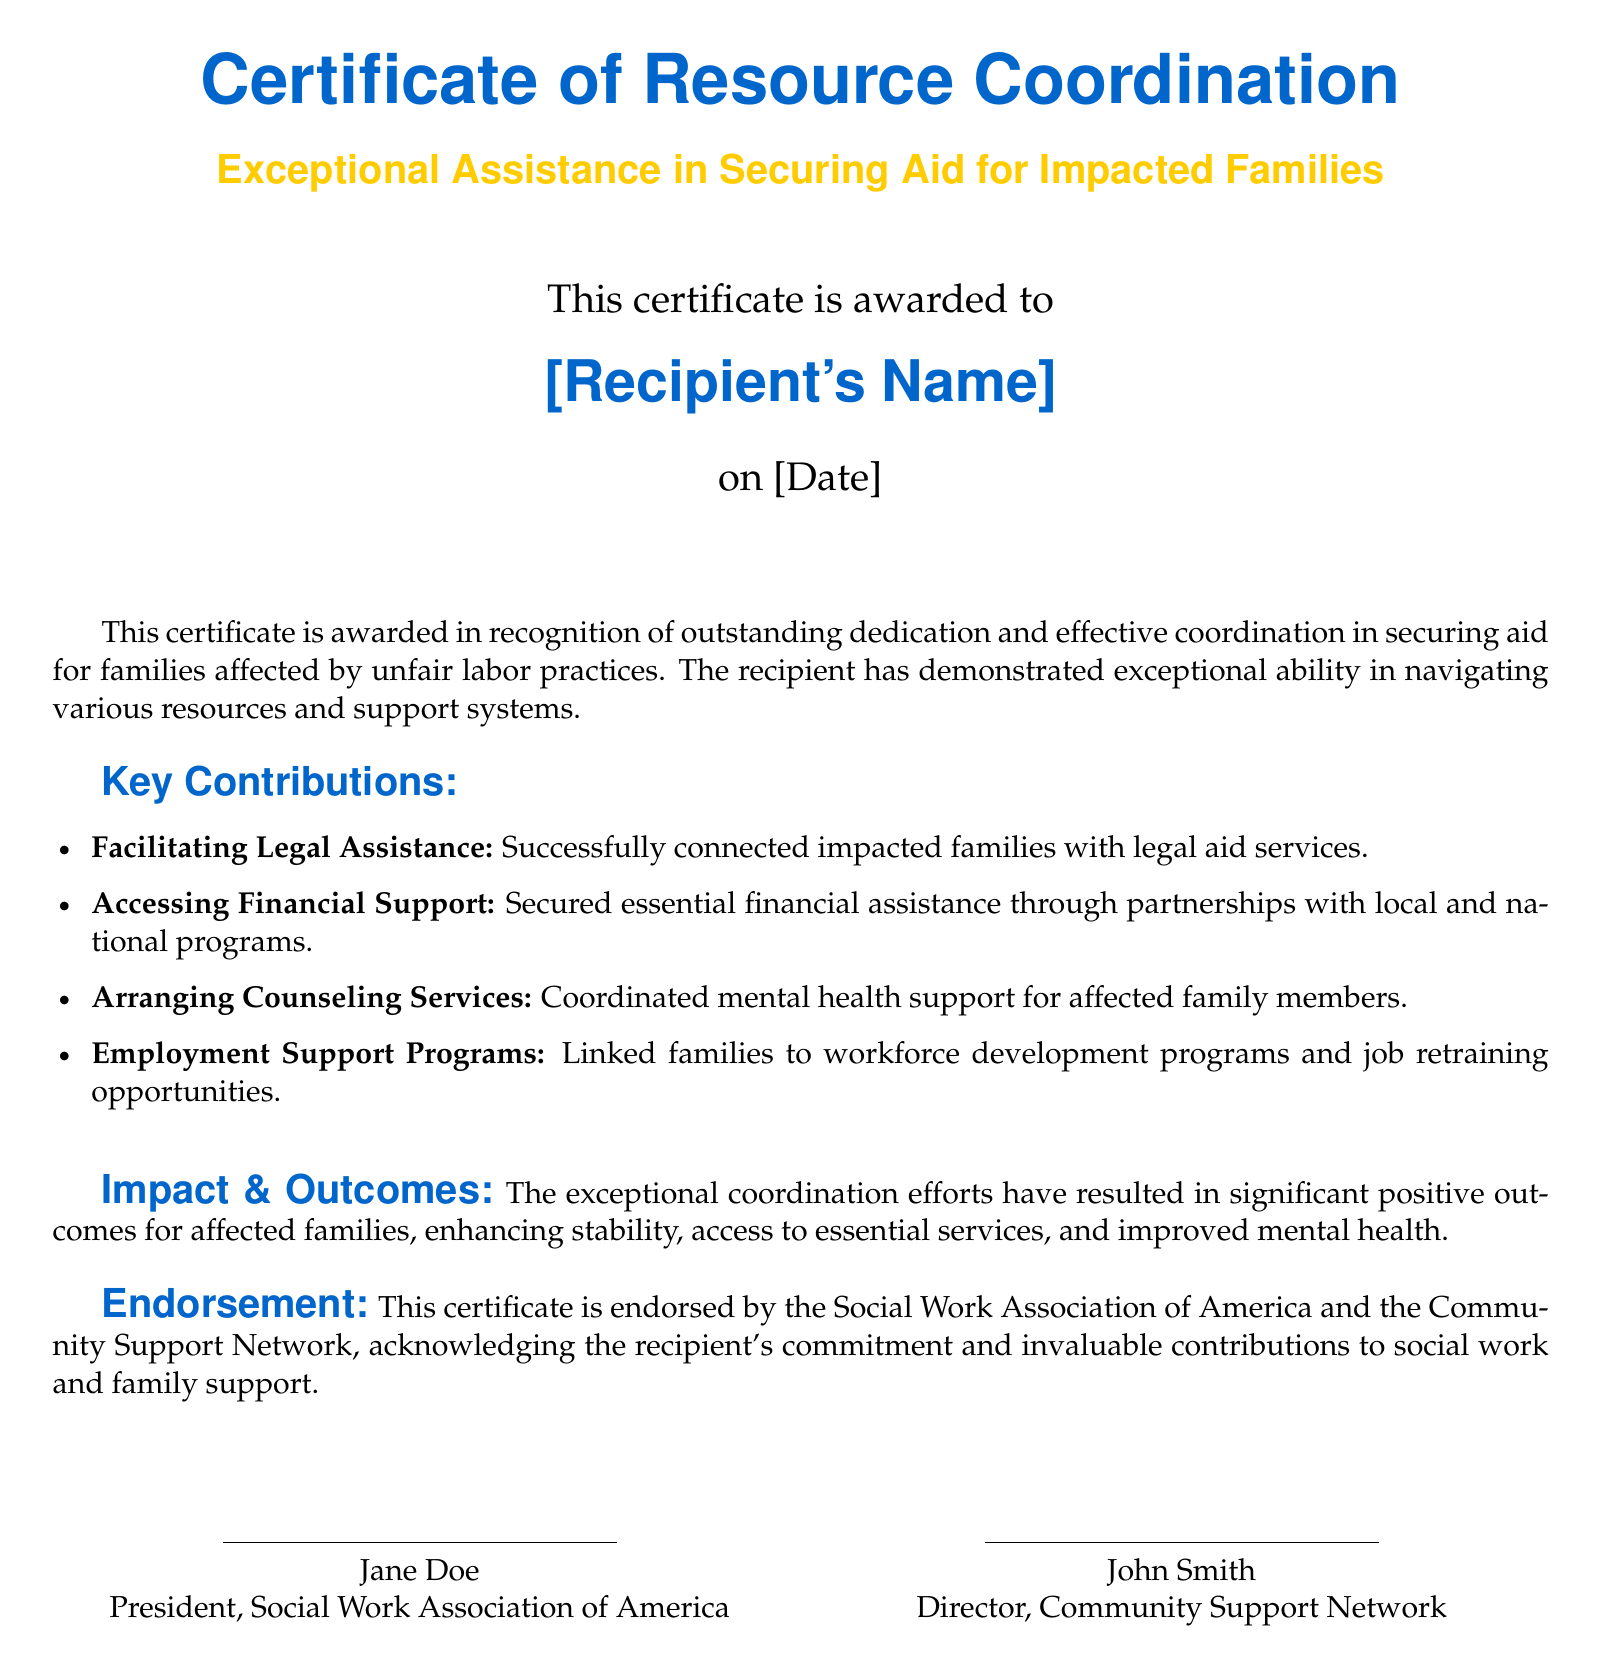What is the title of the certificate? The title is prominently displayed at the top of the document and reads, "Certificate of Resource Coordination."
Answer: Certificate of Resource Coordination Who is the certificate awarded to? The recipient's name is indicated in the document where it states, "This certificate is awarded to [Recipient's Name]."
Answer: [Recipient's Name] What date is the certificate awarded on? The date is mentioned in the document under the recipient's name as "[Date]."
Answer: [Date] What organization endorses the certificate? The document indicates the endorsement by mentioning "Social Work Association of America" and "Community Support Network."
Answer: Social Work Association of America How many key contributions are listed in the document? The number of contributions is found by counting the items listed under "Key Contributions" in the document.
Answer: Four What type of assistance is successfully connected to families? The document explicitly states that legal aid services are facilitated for impacted families.
Answer: Legal Assistance What is a noted outcome of the coordination efforts? The document outlines that the coordination efforts have resulted in "enhancing stability."
Answer: Enhancing stability Who is the president of the endorsing organization? The document provides the name of the president at the bottom as "Jane Doe."
Answer: Jane Doe What does the recipient's work primarily focus on? The purpose of the certificate is to recognize efforts in securing aid for families affected by unfair labor practices, reflecting the focus of the recipient's work.
Answer: Securing aid for impacted families 